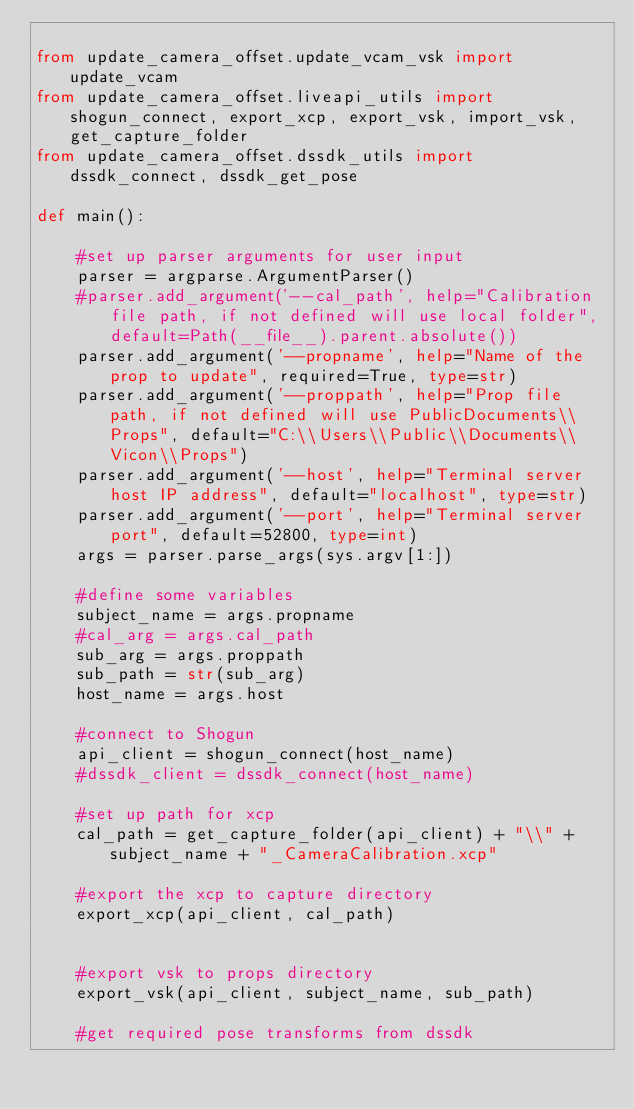Convert code to text. <code><loc_0><loc_0><loc_500><loc_500><_Python_>
from update_camera_offset.update_vcam_vsk import update_vcam
from update_camera_offset.liveapi_utils import shogun_connect, export_xcp, export_vsk, import_vsk, get_capture_folder
from update_camera_offset.dssdk_utils import dssdk_connect, dssdk_get_pose
        
def main():

    #set up parser arguments for user input
    parser = argparse.ArgumentParser()
    #parser.add_argument('--cal_path', help="Calibration file path, if not defined will use local folder", default=Path(__file__).parent.absolute())
    parser.add_argument('--propname', help="Name of the prop to update", required=True, type=str)
    parser.add_argument('--proppath', help="Prop file path, if not defined will use PublicDocuments\\Props", default="C:\\Users\\Public\\Documents\\Vicon\\Props")
    parser.add_argument('--host', help="Terminal server host IP address", default="localhost", type=str)
    parser.add_argument('--port', help="Terminal server port", default=52800, type=int)
    args = parser.parse_args(sys.argv[1:])

    #define some variables
    subject_name = args.propname
    #cal_arg = args.cal_path
    sub_arg = args.proppath
    sub_path = str(sub_arg)
    host_name = args.host
    
    #connect to Shogun
    api_client = shogun_connect(host_name)
    #dssdk_client = dssdk_connect(host_name)

    #set up path for xcp
    cal_path = get_capture_folder(api_client) + "\\" + subject_name + "_CameraCalibration.xcp"
    
    #export the xcp to capture directory
    export_xcp(api_client, cal_path)


    #export vsk to props directory
    export_vsk(api_client, subject_name, sub_path)
    
    #get required pose transforms from dssdk</code> 